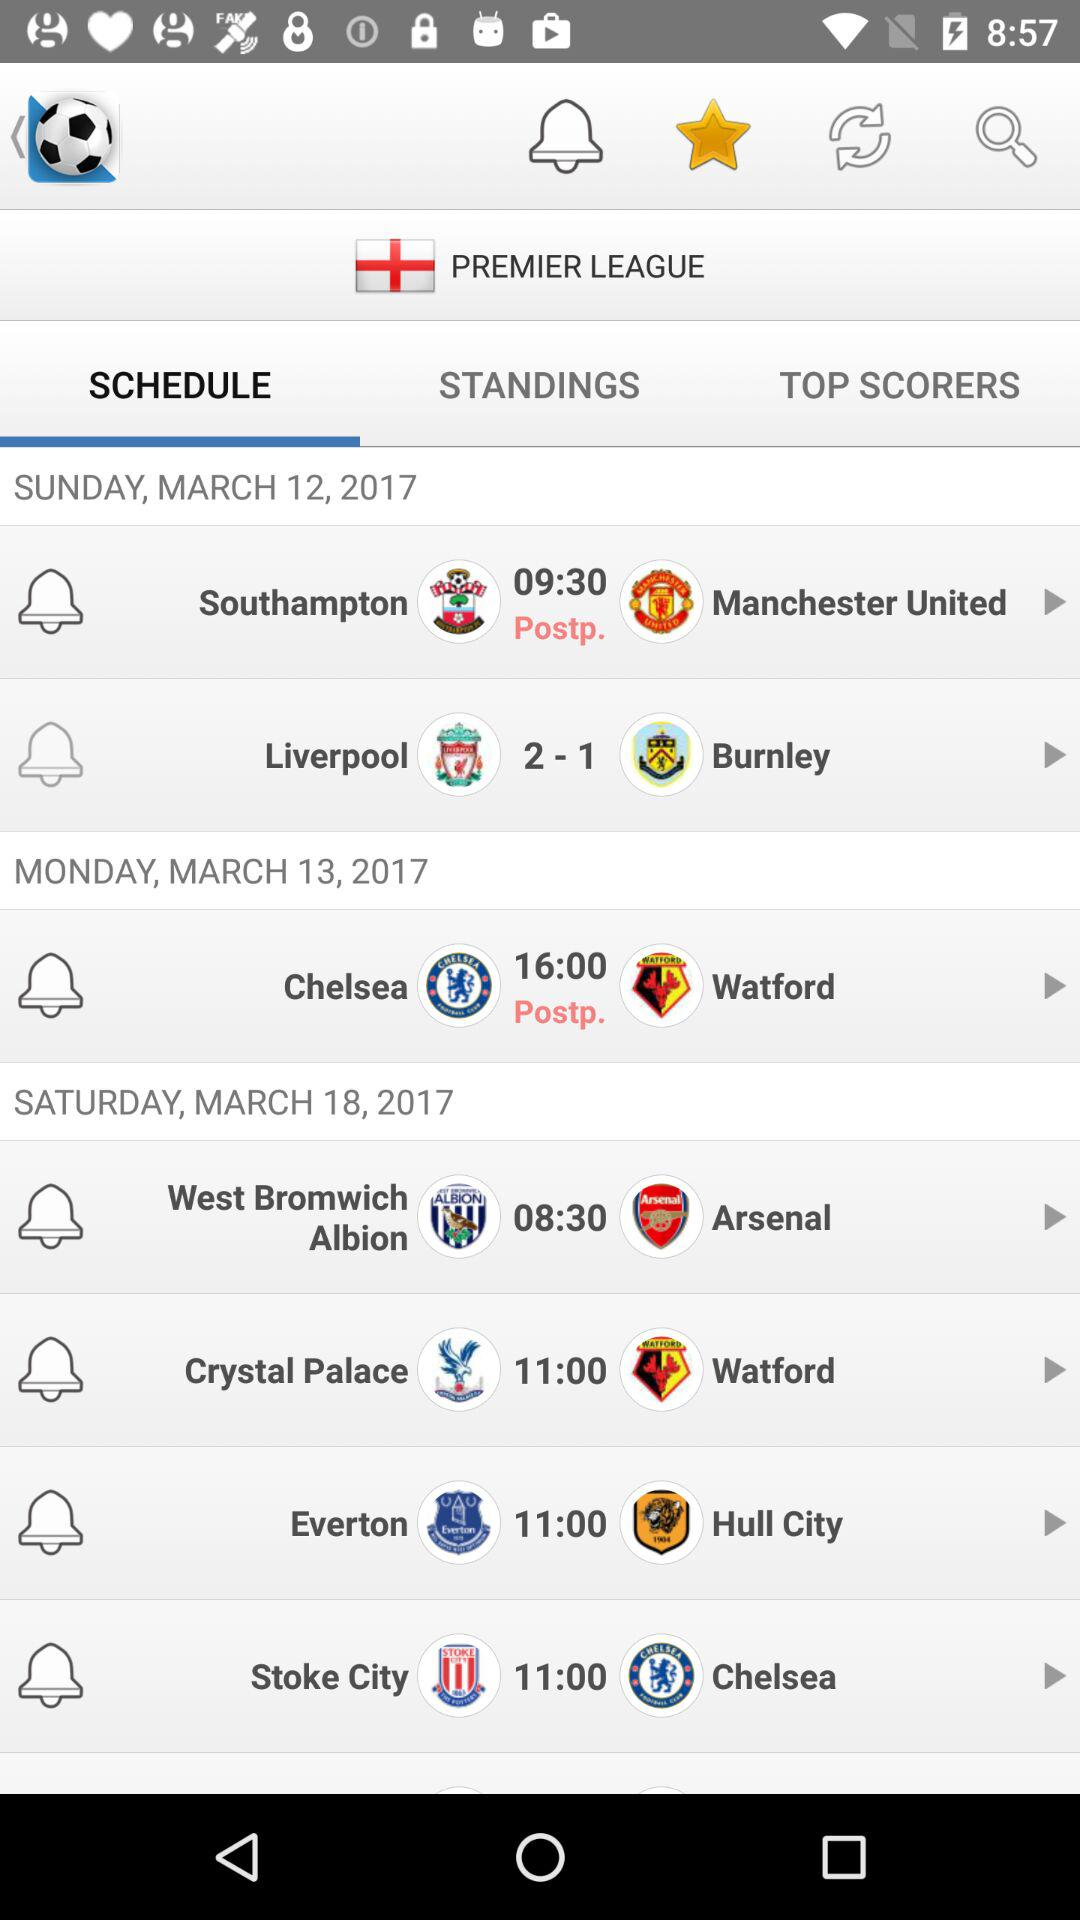What is the score of the "Liverpool" vs. "Burnley" match? The score is "Liverpool": 2 and "Burnley": 1. 